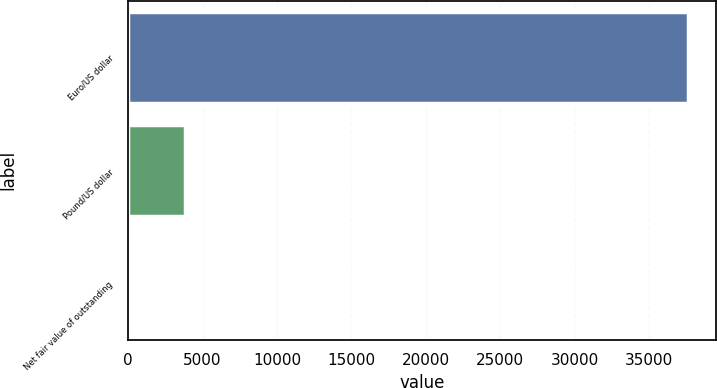Convert chart. <chart><loc_0><loc_0><loc_500><loc_500><bar_chart><fcel>Euro/US dollar<fcel>Pound/US dollar<fcel>Net fair value of outstanding<nl><fcel>37598<fcel>3810<fcel>18<nl></chart> 